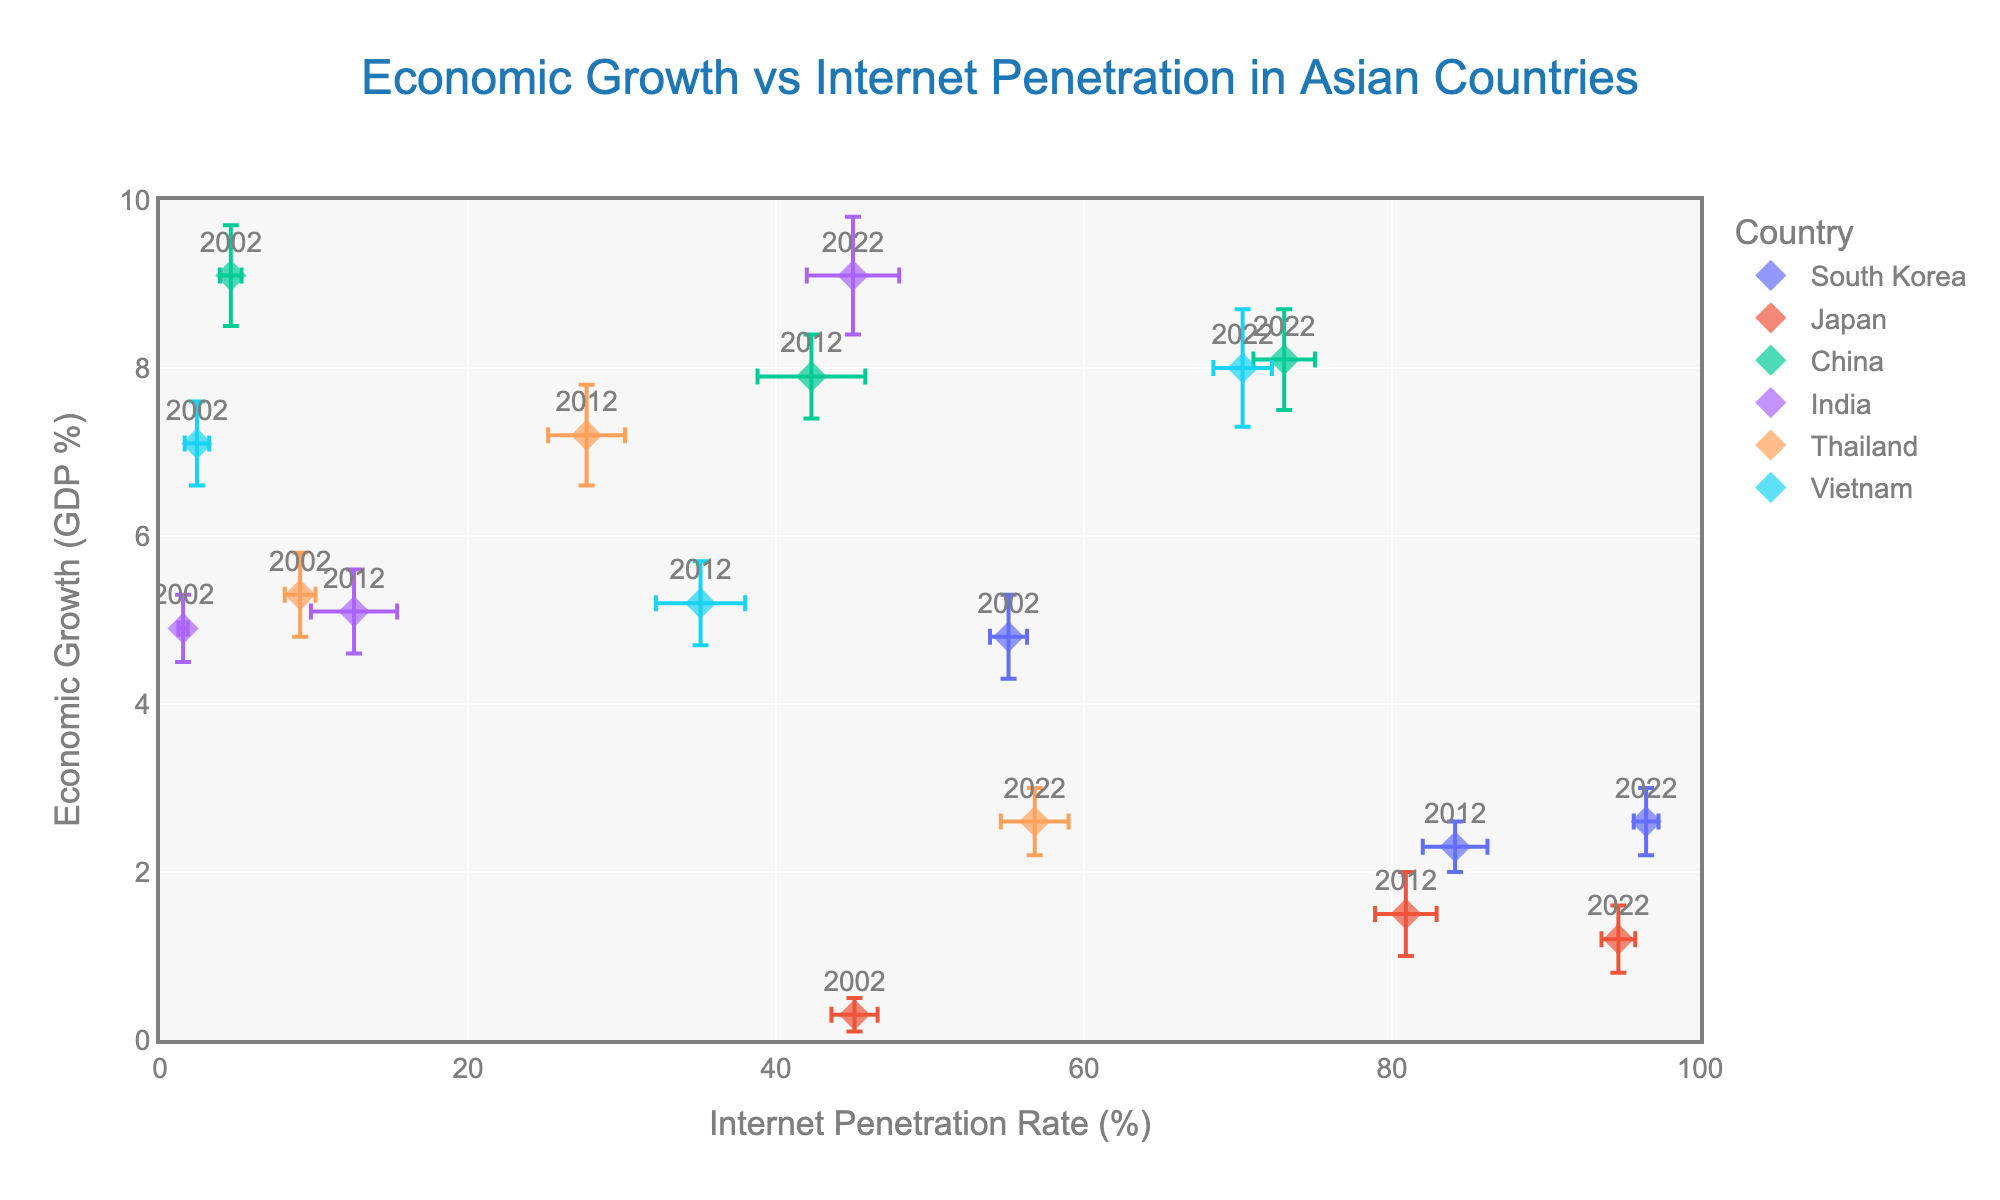What is the title of the figure? The title of the figure is displayed prominently at the top center of the plot. It reads "Economic Growth vs Internet Penetration in Asian Countries."
Answer: Economic Growth vs Internet Penetration in Asian Countries How many countries are represented in the figure? The legend on the right side of the figure lists the countries represented. By counting the number of entries in the legend, you can see that there are six countries.
Answer: Six Which country had the highest internet penetration rate in 2022? We need to look at the text labels on the markers for the year 2022 and find the highest value on the x-axis (Internet Penetration Rate). The marker with the highest internet penetration rate is for South Korea.
Answer: South Korea What was the economic growth rate for India in 2022? Locate the markers for India and find the one labeled with 2022. The corresponding y-axis value (Economic Growth) for that marker is approximately 9.1%.
Answer: 9.1% Which country showed the most significant increase in internet penetration rate from 2002 to 2022? Calculate the difference in internet penetration rates between 2002 and 2022 for each country, then identify the country with the highest difference. South Korea increased from 55.1% to 96.5% (an increase of 41.4%), Japan from 45.1% to 94.7% (an increase of 49.6%), China from 4.6% to 73% (an increase of 68.4%), India from 1.5% to 45% (an increase of 43.5%), Thailand from 9.1% to 56.8% (an increase of 47.7%), and Vietnam from 2.4% to 70.3% (an increase of 67.9%). Therefore, China shows the most significant increase.
Answer: China Between 2002 and 2022, did Japan or Thailand have more consistent economic growth rates? By comparing the economic growth rates in 2002, 2012, and 2022 for Japan and Thailand, we can see how varied the rates are. Japan: 0.3%, 1.5%, 1.2% (variance: 1.44%). Thailand: 5.3%, 7.2%, 2.6% (variance: 5.42%). Japan has more consistent (less varied) economic growth rates than Thailand.
Answer: Japan Which year had the lowest average internet penetration rate across all countries? Calculate the average internet penetration rate for each year as follows: (2002: (55.1 + 45.1 + 4.6 + 1.5 + 9.1 + 2.4) / 6 = 19.63), (2012: (84.1 + 80.9 + 42.3 + 12.6 + 27.7 + 35.1) / 6 = 47.78), (2022: (96.5 + 94.7 + 73 + 45 + 56.8 + 70.3) / 6 = 72.38). 2002 has the lowest average internet penetration rate.
Answer: 2002 What is the relationship between internet penetration rate and economic growth rate for China in 2022? Locate the marker for China in 2022. The x-axis (Internet Penetration Rate) is 73%, and the y-axis (Economic Growth) is 8.1%. This shows relatively high economic growth associated with a moderately high internet penetration rate.
Answer: Moderate-positive For South Korea, how did the economic growth rate change from 2002 to 2022? Compare the economic growth rates in 2002 (4.8%), 2012 (2.3%), and 2022 (2.6%). The growth decreased significantly from 4.8% in 2002 to 2.3% in 2012 and then stayed almost unchanged from 2012 to 2022.
Answer: Decreased 